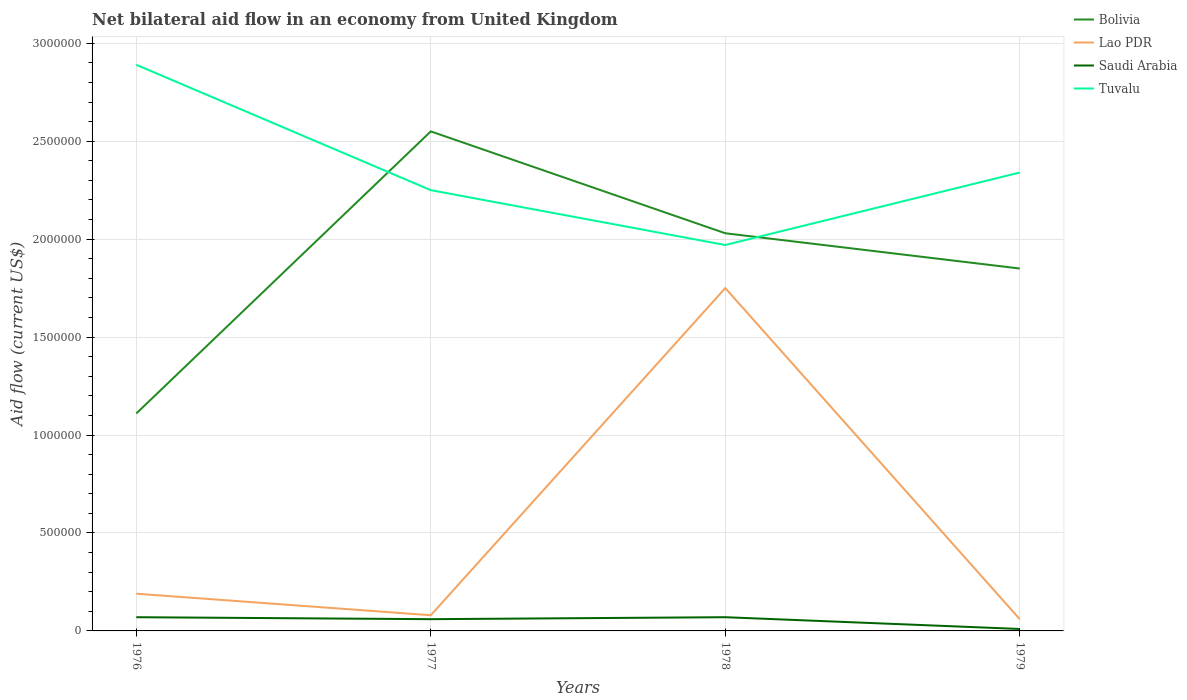Does the line corresponding to Tuvalu intersect with the line corresponding to Bolivia?
Offer a very short reply. Yes. Across all years, what is the maximum net bilateral aid flow in Lao PDR?
Provide a short and direct response. 6.00e+04. In which year was the net bilateral aid flow in Tuvalu maximum?
Keep it short and to the point. 1978. What is the difference between the highest and the second highest net bilateral aid flow in Tuvalu?
Provide a short and direct response. 9.20e+05. Is the net bilateral aid flow in Tuvalu strictly greater than the net bilateral aid flow in Lao PDR over the years?
Keep it short and to the point. No. How many years are there in the graph?
Offer a terse response. 4. How many legend labels are there?
Your answer should be compact. 4. What is the title of the graph?
Make the answer very short. Net bilateral aid flow in an economy from United Kingdom. What is the Aid flow (current US$) in Bolivia in 1976?
Your response must be concise. 1.11e+06. What is the Aid flow (current US$) of Tuvalu in 1976?
Provide a short and direct response. 2.89e+06. What is the Aid flow (current US$) of Bolivia in 1977?
Ensure brevity in your answer.  2.55e+06. What is the Aid flow (current US$) of Lao PDR in 1977?
Ensure brevity in your answer.  8.00e+04. What is the Aid flow (current US$) of Saudi Arabia in 1977?
Give a very brief answer. 6.00e+04. What is the Aid flow (current US$) in Tuvalu in 1977?
Provide a short and direct response. 2.25e+06. What is the Aid flow (current US$) in Bolivia in 1978?
Provide a succinct answer. 2.03e+06. What is the Aid flow (current US$) of Lao PDR in 1978?
Your answer should be very brief. 1.75e+06. What is the Aid flow (current US$) in Saudi Arabia in 1978?
Give a very brief answer. 7.00e+04. What is the Aid flow (current US$) of Tuvalu in 1978?
Make the answer very short. 1.97e+06. What is the Aid flow (current US$) of Bolivia in 1979?
Provide a succinct answer. 1.85e+06. What is the Aid flow (current US$) of Lao PDR in 1979?
Your answer should be very brief. 6.00e+04. What is the Aid flow (current US$) in Saudi Arabia in 1979?
Your answer should be compact. 10000. What is the Aid flow (current US$) of Tuvalu in 1979?
Give a very brief answer. 2.34e+06. Across all years, what is the maximum Aid flow (current US$) in Bolivia?
Ensure brevity in your answer.  2.55e+06. Across all years, what is the maximum Aid flow (current US$) in Lao PDR?
Keep it short and to the point. 1.75e+06. Across all years, what is the maximum Aid flow (current US$) in Saudi Arabia?
Give a very brief answer. 7.00e+04. Across all years, what is the maximum Aid flow (current US$) in Tuvalu?
Make the answer very short. 2.89e+06. Across all years, what is the minimum Aid flow (current US$) of Bolivia?
Offer a very short reply. 1.11e+06. Across all years, what is the minimum Aid flow (current US$) of Lao PDR?
Give a very brief answer. 6.00e+04. Across all years, what is the minimum Aid flow (current US$) of Tuvalu?
Your answer should be very brief. 1.97e+06. What is the total Aid flow (current US$) in Bolivia in the graph?
Your answer should be compact. 7.54e+06. What is the total Aid flow (current US$) of Lao PDR in the graph?
Make the answer very short. 2.08e+06. What is the total Aid flow (current US$) of Saudi Arabia in the graph?
Your answer should be compact. 2.10e+05. What is the total Aid flow (current US$) of Tuvalu in the graph?
Your answer should be compact. 9.45e+06. What is the difference between the Aid flow (current US$) in Bolivia in 1976 and that in 1977?
Provide a short and direct response. -1.44e+06. What is the difference between the Aid flow (current US$) of Saudi Arabia in 1976 and that in 1977?
Your response must be concise. 10000. What is the difference between the Aid flow (current US$) of Tuvalu in 1976 and that in 1977?
Ensure brevity in your answer.  6.40e+05. What is the difference between the Aid flow (current US$) in Bolivia in 1976 and that in 1978?
Offer a terse response. -9.20e+05. What is the difference between the Aid flow (current US$) of Lao PDR in 1976 and that in 1978?
Offer a very short reply. -1.56e+06. What is the difference between the Aid flow (current US$) of Tuvalu in 1976 and that in 1978?
Offer a very short reply. 9.20e+05. What is the difference between the Aid flow (current US$) in Bolivia in 1976 and that in 1979?
Keep it short and to the point. -7.40e+05. What is the difference between the Aid flow (current US$) of Tuvalu in 1976 and that in 1979?
Offer a very short reply. 5.50e+05. What is the difference between the Aid flow (current US$) in Bolivia in 1977 and that in 1978?
Offer a terse response. 5.20e+05. What is the difference between the Aid flow (current US$) of Lao PDR in 1977 and that in 1978?
Offer a terse response. -1.67e+06. What is the difference between the Aid flow (current US$) in Tuvalu in 1977 and that in 1978?
Your answer should be very brief. 2.80e+05. What is the difference between the Aid flow (current US$) in Lao PDR in 1977 and that in 1979?
Your response must be concise. 2.00e+04. What is the difference between the Aid flow (current US$) of Bolivia in 1978 and that in 1979?
Make the answer very short. 1.80e+05. What is the difference between the Aid flow (current US$) of Lao PDR in 1978 and that in 1979?
Ensure brevity in your answer.  1.69e+06. What is the difference between the Aid flow (current US$) of Tuvalu in 1978 and that in 1979?
Offer a very short reply. -3.70e+05. What is the difference between the Aid flow (current US$) in Bolivia in 1976 and the Aid flow (current US$) in Lao PDR in 1977?
Provide a short and direct response. 1.03e+06. What is the difference between the Aid flow (current US$) of Bolivia in 1976 and the Aid flow (current US$) of Saudi Arabia in 1977?
Ensure brevity in your answer.  1.05e+06. What is the difference between the Aid flow (current US$) of Bolivia in 1976 and the Aid flow (current US$) of Tuvalu in 1977?
Ensure brevity in your answer.  -1.14e+06. What is the difference between the Aid flow (current US$) of Lao PDR in 1976 and the Aid flow (current US$) of Tuvalu in 1977?
Make the answer very short. -2.06e+06. What is the difference between the Aid flow (current US$) in Saudi Arabia in 1976 and the Aid flow (current US$) in Tuvalu in 1977?
Ensure brevity in your answer.  -2.18e+06. What is the difference between the Aid flow (current US$) of Bolivia in 1976 and the Aid flow (current US$) of Lao PDR in 1978?
Your answer should be compact. -6.40e+05. What is the difference between the Aid flow (current US$) of Bolivia in 1976 and the Aid flow (current US$) of Saudi Arabia in 1978?
Offer a terse response. 1.04e+06. What is the difference between the Aid flow (current US$) of Bolivia in 1976 and the Aid flow (current US$) of Tuvalu in 1978?
Keep it short and to the point. -8.60e+05. What is the difference between the Aid flow (current US$) in Lao PDR in 1976 and the Aid flow (current US$) in Saudi Arabia in 1978?
Provide a succinct answer. 1.20e+05. What is the difference between the Aid flow (current US$) of Lao PDR in 1976 and the Aid flow (current US$) of Tuvalu in 1978?
Your answer should be compact. -1.78e+06. What is the difference between the Aid flow (current US$) of Saudi Arabia in 1976 and the Aid flow (current US$) of Tuvalu in 1978?
Provide a short and direct response. -1.90e+06. What is the difference between the Aid flow (current US$) of Bolivia in 1976 and the Aid flow (current US$) of Lao PDR in 1979?
Ensure brevity in your answer.  1.05e+06. What is the difference between the Aid flow (current US$) of Bolivia in 1976 and the Aid flow (current US$) of Saudi Arabia in 1979?
Your response must be concise. 1.10e+06. What is the difference between the Aid flow (current US$) of Bolivia in 1976 and the Aid flow (current US$) of Tuvalu in 1979?
Offer a very short reply. -1.23e+06. What is the difference between the Aid flow (current US$) in Lao PDR in 1976 and the Aid flow (current US$) in Saudi Arabia in 1979?
Your response must be concise. 1.80e+05. What is the difference between the Aid flow (current US$) of Lao PDR in 1976 and the Aid flow (current US$) of Tuvalu in 1979?
Offer a terse response. -2.15e+06. What is the difference between the Aid flow (current US$) in Saudi Arabia in 1976 and the Aid flow (current US$) in Tuvalu in 1979?
Offer a terse response. -2.27e+06. What is the difference between the Aid flow (current US$) in Bolivia in 1977 and the Aid flow (current US$) in Lao PDR in 1978?
Your answer should be very brief. 8.00e+05. What is the difference between the Aid flow (current US$) in Bolivia in 1977 and the Aid flow (current US$) in Saudi Arabia in 1978?
Your answer should be very brief. 2.48e+06. What is the difference between the Aid flow (current US$) of Bolivia in 1977 and the Aid flow (current US$) of Tuvalu in 1978?
Provide a short and direct response. 5.80e+05. What is the difference between the Aid flow (current US$) of Lao PDR in 1977 and the Aid flow (current US$) of Saudi Arabia in 1978?
Provide a short and direct response. 10000. What is the difference between the Aid flow (current US$) in Lao PDR in 1977 and the Aid flow (current US$) in Tuvalu in 1978?
Offer a very short reply. -1.89e+06. What is the difference between the Aid flow (current US$) in Saudi Arabia in 1977 and the Aid flow (current US$) in Tuvalu in 1978?
Your answer should be compact. -1.91e+06. What is the difference between the Aid flow (current US$) of Bolivia in 1977 and the Aid flow (current US$) of Lao PDR in 1979?
Keep it short and to the point. 2.49e+06. What is the difference between the Aid flow (current US$) of Bolivia in 1977 and the Aid flow (current US$) of Saudi Arabia in 1979?
Your answer should be very brief. 2.54e+06. What is the difference between the Aid flow (current US$) in Bolivia in 1977 and the Aid flow (current US$) in Tuvalu in 1979?
Ensure brevity in your answer.  2.10e+05. What is the difference between the Aid flow (current US$) of Lao PDR in 1977 and the Aid flow (current US$) of Saudi Arabia in 1979?
Provide a succinct answer. 7.00e+04. What is the difference between the Aid flow (current US$) in Lao PDR in 1977 and the Aid flow (current US$) in Tuvalu in 1979?
Give a very brief answer. -2.26e+06. What is the difference between the Aid flow (current US$) in Saudi Arabia in 1977 and the Aid flow (current US$) in Tuvalu in 1979?
Provide a short and direct response. -2.28e+06. What is the difference between the Aid flow (current US$) of Bolivia in 1978 and the Aid flow (current US$) of Lao PDR in 1979?
Ensure brevity in your answer.  1.97e+06. What is the difference between the Aid flow (current US$) of Bolivia in 1978 and the Aid flow (current US$) of Saudi Arabia in 1979?
Keep it short and to the point. 2.02e+06. What is the difference between the Aid flow (current US$) of Bolivia in 1978 and the Aid flow (current US$) of Tuvalu in 1979?
Ensure brevity in your answer.  -3.10e+05. What is the difference between the Aid flow (current US$) in Lao PDR in 1978 and the Aid flow (current US$) in Saudi Arabia in 1979?
Your response must be concise. 1.74e+06. What is the difference between the Aid flow (current US$) of Lao PDR in 1978 and the Aid flow (current US$) of Tuvalu in 1979?
Your answer should be compact. -5.90e+05. What is the difference between the Aid flow (current US$) in Saudi Arabia in 1978 and the Aid flow (current US$) in Tuvalu in 1979?
Provide a succinct answer. -2.27e+06. What is the average Aid flow (current US$) in Bolivia per year?
Ensure brevity in your answer.  1.88e+06. What is the average Aid flow (current US$) in Lao PDR per year?
Give a very brief answer. 5.20e+05. What is the average Aid flow (current US$) in Saudi Arabia per year?
Give a very brief answer. 5.25e+04. What is the average Aid flow (current US$) in Tuvalu per year?
Provide a short and direct response. 2.36e+06. In the year 1976, what is the difference between the Aid flow (current US$) in Bolivia and Aid flow (current US$) in Lao PDR?
Your response must be concise. 9.20e+05. In the year 1976, what is the difference between the Aid flow (current US$) of Bolivia and Aid flow (current US$) of Saudi Arabia?
Your answer should be compact. 1.04e+06. In the year 1976, what is the difference between the Aid flow (current US$) of Bolivia and Aid flow (current US$) of Tuvalu?
Ensure brevity in your answer.  -1.78e+06. In the year 1976, what is the difference between the Aid flow (current US$) in Lao PDR and Aid flow (current US$) in Saudi Arabia?
Your response must be concise. 1.20e+05. In the year 1976, what is the difference between the Aid flow (current US$) of Lao PDR and Aid flow (current US$) of Tuvalu?
Offer a terse response. -2.70e+06. In the year 1976, what is the difference between the Aid flow (current US$) in Saudi Arabia and Aid flow (current US$) in Tuvalu?
Your response must be concise. -2.82e+06. In the year 1977, what is the difference between the Aid flow (current US$) of Bolivia and Aid flow (current US$) of Lao PDR?
Provide a succinct answer. 2.47e+06. In the year 1977, what is the difference between the Aid flow (current US$) of Bolivia and Aid flow (current US$) of Saudi Arabia?
Keep it short and to the point. 2.49e+06. In the year 1977, what is the difference between the Aid flow (current US$) in Bolivia and Aid flow (current US$) in Tuvalu?
Your answer should be compact. 3.00e+05. In the year 1977, what is the difference between the Aid flow (current US$) of Lao PDR and Aid flow (current US$) of Tuvalu?
Your answer should be compact. -2.17e+06. In the year 1977, what is the difference between the Aid flow (current US$) of Saudi Arabia and Aid flow (current US$) of Tuvalu?
Provide a short and direct response. -2.19e+06. In the year 1978, what is the difference between the Aid flow (current US$) in Bolivia and Aid flow (current US$) in Saudi Arabia?
Provide a succinct answer. 1.96e+06. In the year 1978, what is the difference between the Aid flow (current US$) in Lao PDR and Aid flow (current US$) in Saudi Arabia?
Give a very brief answer. 1.68e+06. In the year 1978, what is the difference between the Aid flow (current US$) in Saudi Arabia and Aid flow (current US$) in Tuvalu?
Keep it short and to the point. -1.90e+06. In the year 1979, what is the difference between the Aid flow (current US$) in Bolivia and Aid flow (current US$) in Lao PDR?
Make the answer very short. 1.79e+06. In the year 1979, what is the difference between the Aid flow (current US$) of Bolivia and Aid flow (current US$) of Saudi Arabia?
Keep it short and to the point. 1.84e+06. In the year 1979, what is the difference between the Aid flow (current US$) in Bolivia and Aid flow (current US$) in Tuvalu?
Offer a very short reply. -4.90e+05. In the year 1979, what is the difference between the Aid flow (current US$) in Lao PDR and Aid flow (current US$) in Saudi Arabia?
Offer a very short reply. 5.00e+04. In the year 1979, what is the difference between the Aid flow (current US$) in Lao PDR and Aid flow (current US$) in Tuvalu?
Your response must be concise. -2.28e+06. In the year 1979, what is the difference between the Aid flow (current US$) in Saudi Arabia and Aid flow (current US$) in Tuvalu?
Your answer should be compact. -2.33e+06. What is the ratio of the Aid flow (current US$) of Bolivia in 1976 to that in 1977?
Offer a very short reply. 0.44. What is the ratio of the Aid flow (current US$) in Lao PDR in 1976 to that in 1977?
Provide a succinct answer. 2.38. What is the ratio of the Aid flow (current US$) in Saudi Arabia in 1976 to that in 1977?
Provide a succinct answer. 1.17. What is the ratio of the Aid flow (current US$) in Tuvalu in 1976 to that in 1977?
Keep it short and to the point. 1.28. What is the ratio of the Aid flow (current US$) in Bolivia in 1976 to that in 1978?
Provide a succinct answer. 0.55. What is the ratio of the Aid flow (current US$) in Lao PDR in 1976 to that in 1978?
Your response must be concise. 0.11. What is the ratio of the Aid flow (current US$) in Saudi Arabia in 1976 to that in 1978?
Your response must be concise. 1. What is the ratio of the Aid flow (current US$) of Tuvalu in 1976 to that in 1978?
Provide a short and direct response. 1.47. What is the ratio of the Aid flow (current US$) of Bolivia in 1976 to that in 1979?
Offer a very short reply. 0.6. What is the ratio of the Aid flow (current US$) in Lao PDR in 1976 to that in 1979?
Give a very brief answer. 3.17. What is the ratio of the Aid flow (current US$) in Saudi Arabia in 1976 to that in 1979?
Your answer should be very brief. 7. What is the ratio of the Aid flow (current US$) of Tuvalu in 1976 to that in 1979?
Ensure brevity in your answer.  1.24. What is the ratio of the Aid flow (current US$) in Bolivia in 1977 to that in 1978?
Your answer should be compact. 1.26. What is the ratio of the Aid flow (current US$) in Lao PDR in 1977 to that in 1978?
Keep it short and to the point. 0.05. What is the ratio of the Aid flow (current US$) in Saudi Arabia in 1977 to that in 1978?
Provide a succinct answer. 0.86. What is the ratio of the Aid flow (current US$) in Tuvalu in 1977 to that in 1978?
Ensure brevity in your answer.  1.14. What is the ratio of the Aid flow (current US$) of Bolivia in 1977 to that in 1979?
Ensure brevity in your answer.  1.38. What is the ratio of the Aid flow (current US$) in Lao PDR in 1977 to that in 1979?
Keep it short and to the point. 1.33. What is the ratio of the Aid flow (current US$) of Tuvalu in 1977 to that in 1979?
Keep it short and to the point. 0.96. What is the ratio of the Aid flow (current US$) in Bolivia in 1978 to that in 1979?
Your response must be concise. 1.1. What is the ratio of the Aid flow (current US$) in Lao PDR in 1978 to that in 1979?
Your answer should be compact. 29.17. What is the ratio of the Aid flow (current US$) of Tuvalu in 1978 to that in 1979?
Provide a short and direct response. 0.84. What is the difference between the highest and the second highest Aid flow (current US$) of Bolivia?
Your answer should be very brief. 5.20e+05. What is the difference between the highest and the second highest Aid flow (current US$) in Lao PDR?
Provide a short and direct response. 1.56e+06. What is the difference between the highest and the second highest Aid flow (current US$) in Saudi Arabia?
Provide a short and direct response. 0. What is the difference between the highest and the lowest Aid flow (current US$) in Bolivia?
Ensure brevity in your answer.  1.44e+06. What is the difference between the highest and the lowest Aid flow (current US$) of Lao PDR?
Make the answer very short. 1.69e+06. What is the difference between the highest and the lowest Aid flow (current US$) in Saudi Arabia?
Keep it short and to the point. 6.00e+04. What is the difference between the highest and the lowest Aid flow (current US$) of Tuvalu?
Keep it short and to the point. 9.20e+05. 